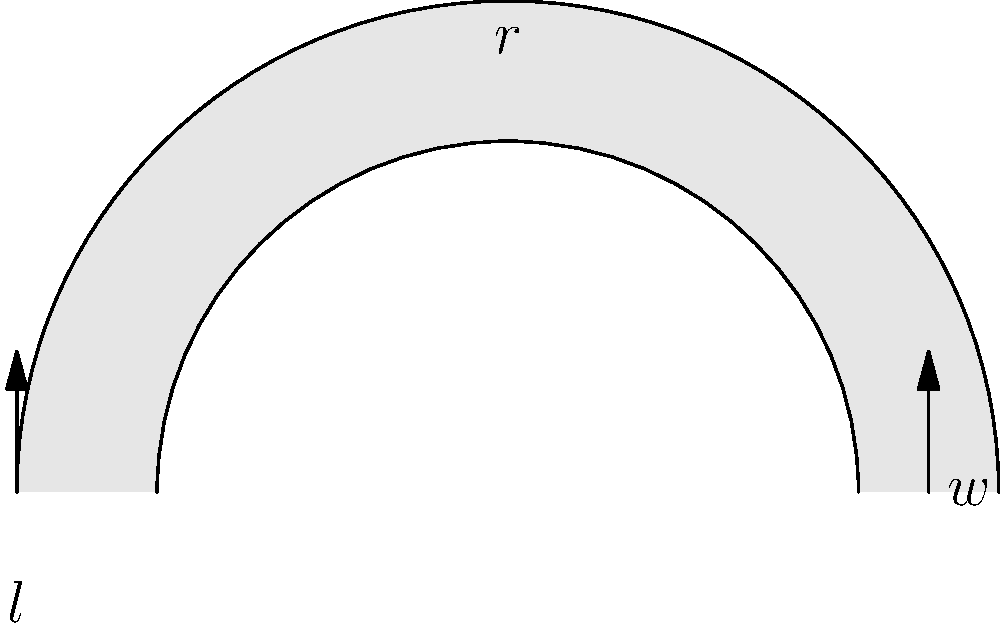A new curved pathway is being added to the neighborhood park. The path has an inner radius of 10 feet, is 4 feet wide, and extends for a length of 50 feet along its outer edge. If the concrete needs to be poured 6 inches deep, how many cubic yards of concrete are required for this project? (Round your answer to the nearest tenth of a cubic yard.) Let's approach this step-by-step:

1) First, we need to calculate the area of the curved path:
   - Outer radius: $R = 10 + 4 = 14$ feet
   - Inner radius: $r = 10$ feet
   - Arc length: $50$ feet

2) The area of a circular sector is given by $A = \frac{1}{2}r^2\theta$, where $\theta$ is in radians.
   We can find $\theta$ using the arc length formula: $s = r\theta$
   $\theta = \frac{s}{r} = \frac{50}{14} \approx 3.5714$ radians

3) Now we can calculate the areas:
   - Outer sector: $A_1 = \frac{1}{2} \cdot 14^2 \cdot 3.5714 = 349.9972$ sq ft
   - Inner sector: $A_2 = \frac{1}{2} \cdot 10^2 \cdot 3.5714 = 178.57$ sq ft

4) The area of the path is the difference: $A = A_1 - A_2 = 171.4272$ sq ft

5) To find the volume, we multiply by the depth:
   $V = 171.4272 \cdot 0.5 = 85.7136$ cubic feet

6) Convert cubic feet to cubic yards:
   $85.7136 \div 27 \approx 3.1746$ cubic yards

7) Rounding to the nearest tenth: $3.2$ cubic yards
Answer: 3.2 cubic yards 